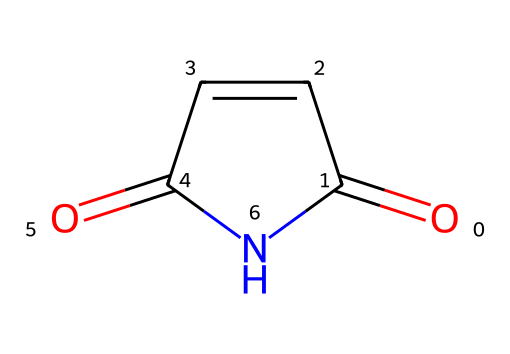What is the molecular formula of maleimide? By examining the chemical structure, you can count each type of atom present. The structure reveals 4 carbon atoms, 4 hydrogen atoms, 2 oxygen atoms, and 1 nitrogen atom, thereby yielding the molecular formula C4H4N2O2.
Answer: C4H4N2O2 How many rings are present in the structure of maleimide? The rendered chemical structure shows a cyclic structure formed by a five-membered ring. Thus, there is one ring present in maleimide.
Answer: 1 What type of functional group does maleimide contain? Looking at the structure, maleimide features both imide and carbonyl functional groups, characterized by the presence of the nitrogen atom bonded to two carbonyl groups.
Answer: imide What is the number of double bonds in maleimide? Upon inspecting the structure, there are two double bonds evident; one is between carbon and nitrogen, and the other is between carbon and oxygen.
Answer: 2 What is the significance of the nitrogen atom in maleimide's structure? The nitrogen atom reveals that maleimide is an imide, directly influencing its reactivity in bioconjugation reactions and polymer chemistry, thus impacting its applications widely.
Answer: imide How does the structure of maleimide contribute to its stability? The presence of the imide bond, which is characterized by resonance stabilization whereby the lone pair of electrons on nitrogen can delocalize, contributes significantly to the overall stability of the molecule.
Answer: stability 